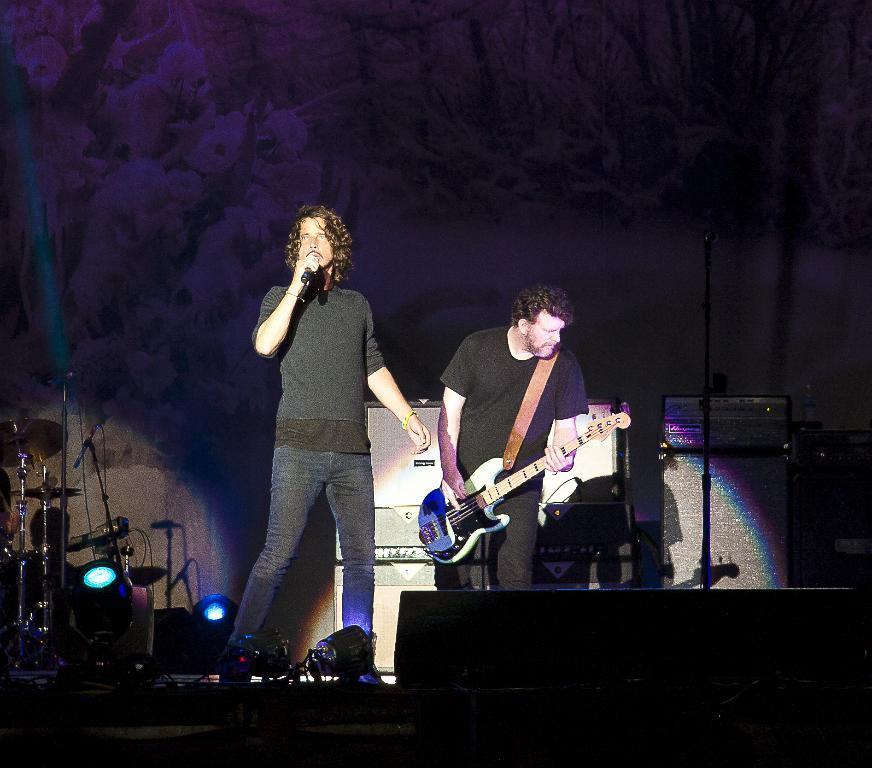Please provide a concise description of this image. The picture is taken in a musical concert where a guy is singing and another guy beside him is playing a guitar. In the background we observe many musical instruments and few black boxes kept on the right side of the image. There are also two LED lights focusing on the musicians. The background is violet color and beautifully designed. 